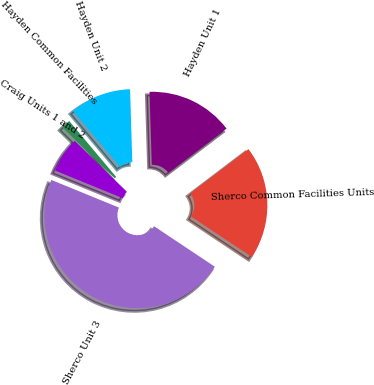Convert chart to OTSL. <chart><loc_0><loc_0><loc_500><loc_500><pie_chart><fcel>Sherco Unit 3<fcel>Sherco Common Facilities Units<fcel>Hayden Unit 1<fcel>Hayden Unit 2<fcel>Hayden Common Facilities<fcel>Craig Units 1 and 2<nl><fcel>46.83%<fcel>19.68%<fcel>15.16%<fcel>10.63%<fcel>1.59%<fcel>6.11%<nl></chart> 